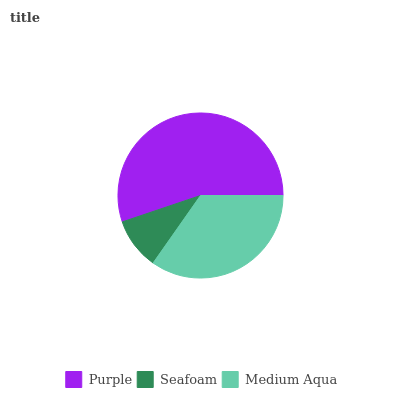Is Seafoam the minimum?
Answer yes or no. Yes. Is Purple the maximum?
Answer yes or no. Yes. Is Medium Aqua the minimum?
Answer yes or no. No. Is Medium Aqua the maximum?
Answer yes or no. No. Is Medium Aqua greater than Seafoam?
Answer yes or no. Yes. Is Seafoam less than Medium Aqua?
Answer yes or no. Yes. Is Seafoam greater than Medium Aqua?
Answer yes or no. No. Is Medium Aqua less than Seafoam?
Answer yes or no. No. Is Medium Aqua the high median?
Answer yes or no. Yes. Is Medium Aqua the low median?
Answer yes or no. Yes. Is Seafoam the high median?
Answer yes or no. No. Is Purple the low median?
Answer yes or no. No. 